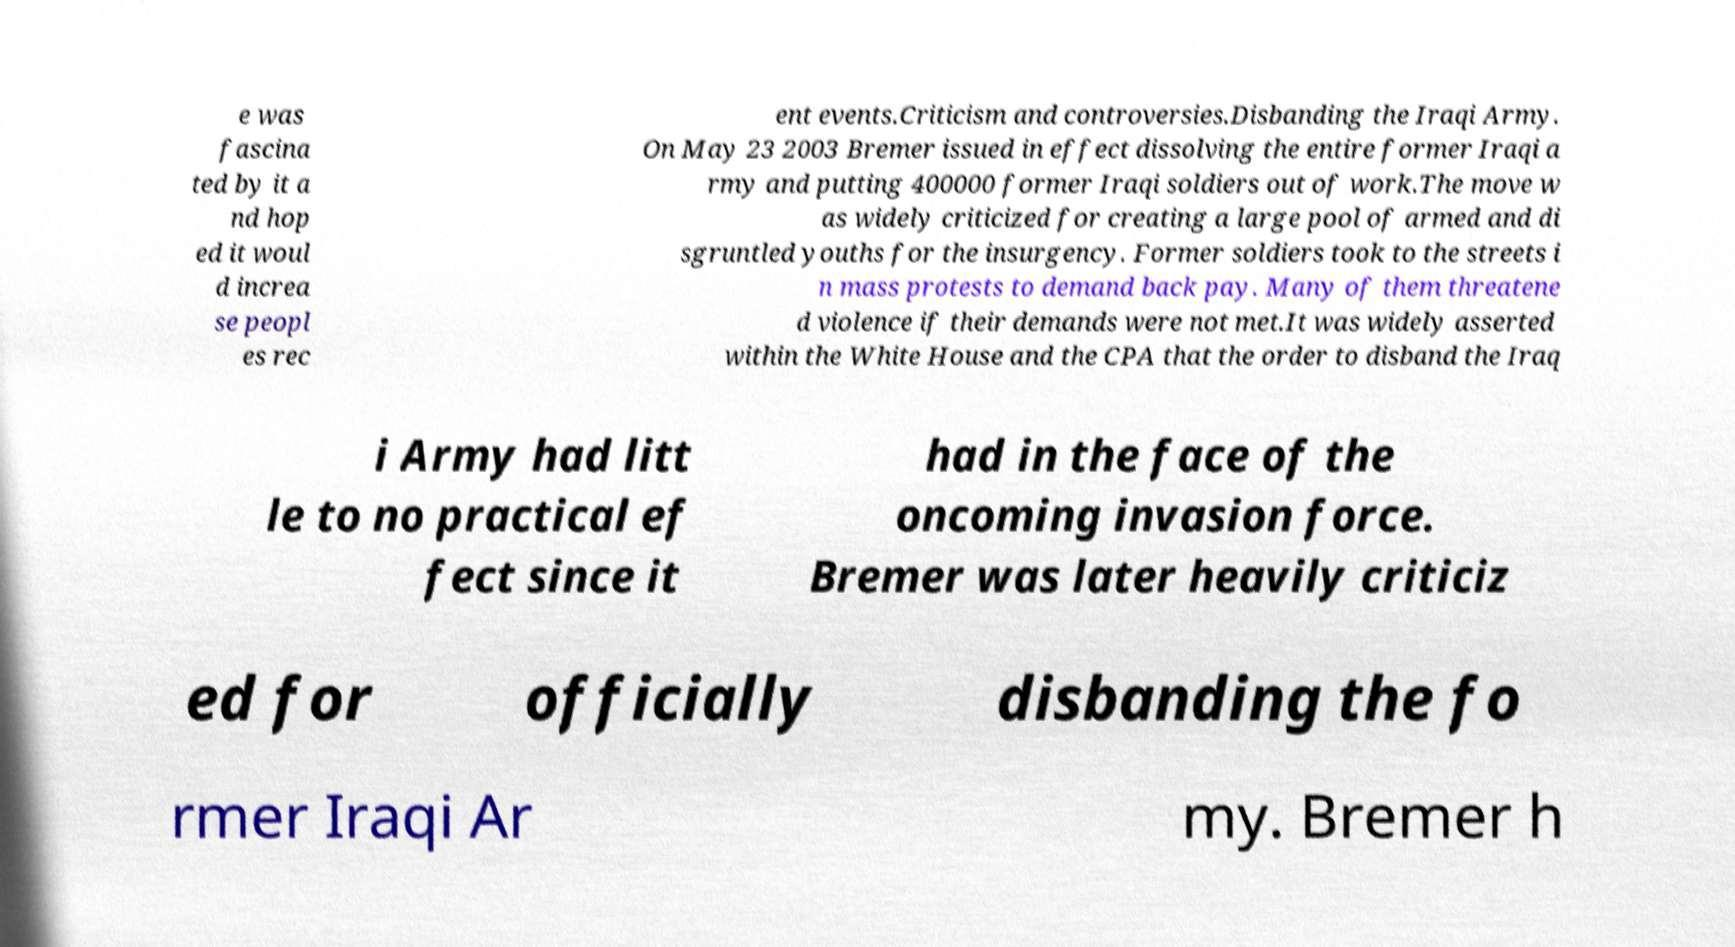Could you extract and type out the text from this image? e was fascina ted by it a nd hop ed it woul d increa se peopl es rec ent events.Criticism and controversies.Disbanding the Iraqi Army. On May 23 2003 Bremer issued in effect dissolving the entire former Iraqi a rmy and putting 400000 former Iraqi soldiers out of work.The move w as widely criticized for creating a large pool of armed and di sgruntled youths for the insurgency. Former soldiers took to the streets i n mass protests to demand back pay. Many of them threatene d violence if their demands were not met.It was widely asserted within the White House and the CPA that the order to disband the Iraq i Army had litt le to no practical ef fect since it had in the face of the oncoming invasion force. Bremer was later heavily criticiz ed for officially disbanding the fo rmer Iraqi Ar my. Bremer h 